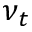<formula> <loc_0><loc_0><loc_500><loc_500>\nu _ { t }</formula> 